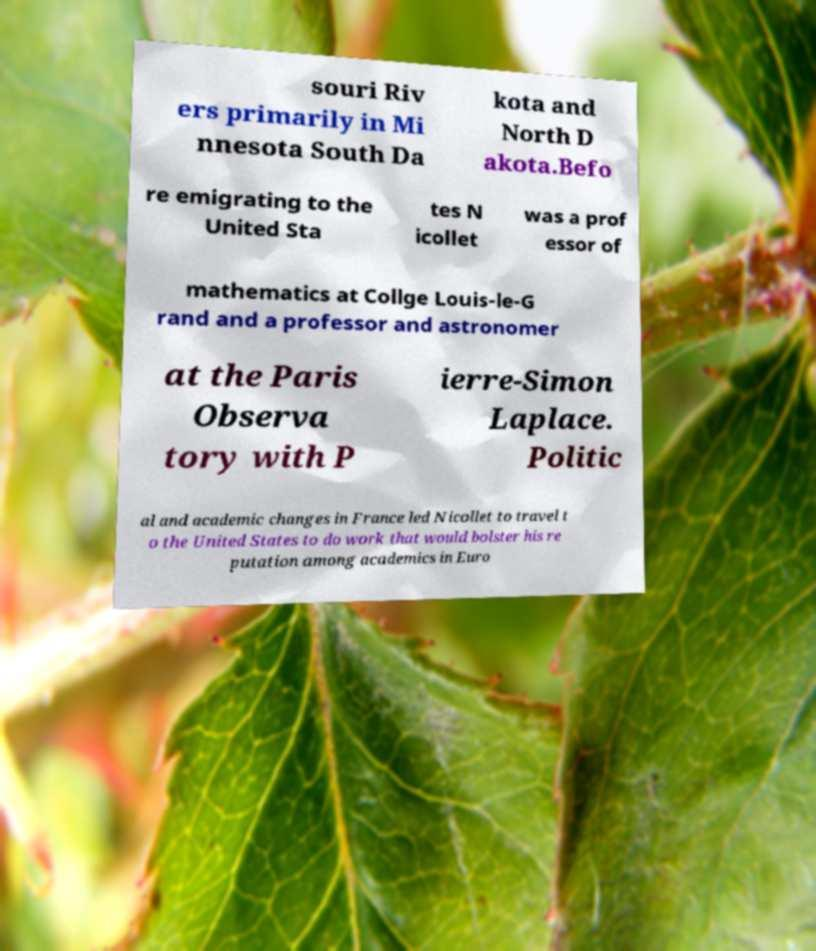Could you assist in decoding the text presented in this image and type it out clearly? souri Riv ers primarily in Mi nnesota South Da kota and North D akota.Befo re emigrating to the United Sta tes N icollet was a prof essor of mathematics at Collge Louis-le-G rand and a professor and astronomer at the Paris Observa tory with P ierre-Simon Laplace. Politic al and academic changes in France led Nicollet to travel t o the United States to do work that would bolster his re putation among academics in Euro 